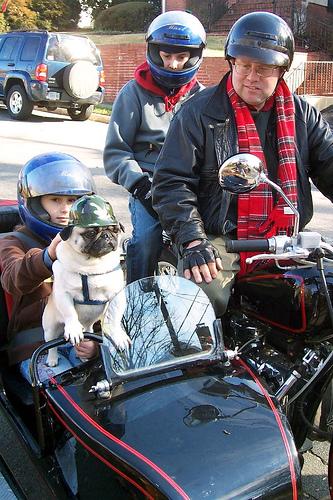Is there a pug in the vehicle?
Write a very short answer. Yes. Where is the dog?
Give a very brief answer. Sidecar. What brand bike is this?
Keep it brief. Harley davidson. How many people are wearing helmets?
Write a very short answer. 3. 